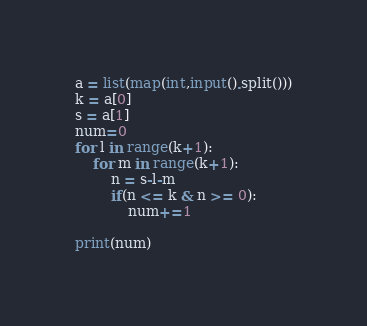Convert code to text. <code><loc_0><loc_0><loc_500><loc_500><_Python_>a = list(map(int,input().split()))
k = a[0]
s = a[1]
num=0
for l in range(k+1):
    for m in range(k+1):
        n = s-l-m
        if(n <= k & n >= 0):
            num+=1

print(num)
</code> 